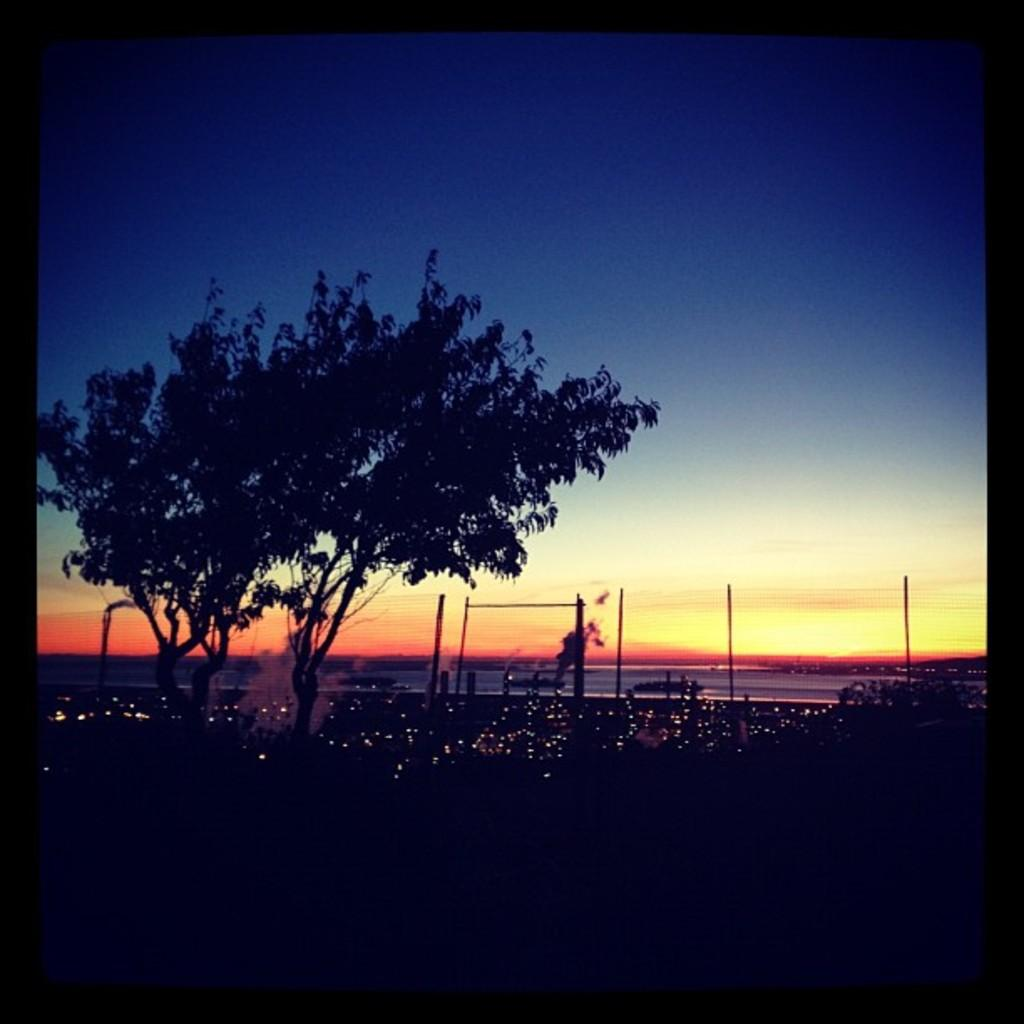What type of vegetation can be seen in the image? There are trees in the image. What structures are present in the image? There are poles in the image. What is visible in the background of the image? The sky is visible in the image. Can you tell me how many pickles are hanging from the trees in the image? There are no pickles present in the image; it features trees and poles. What type of beast can be seen interacting with the poles in the image? There is: There is no beast present in the image; only trees, poles, and the sky are visible. 